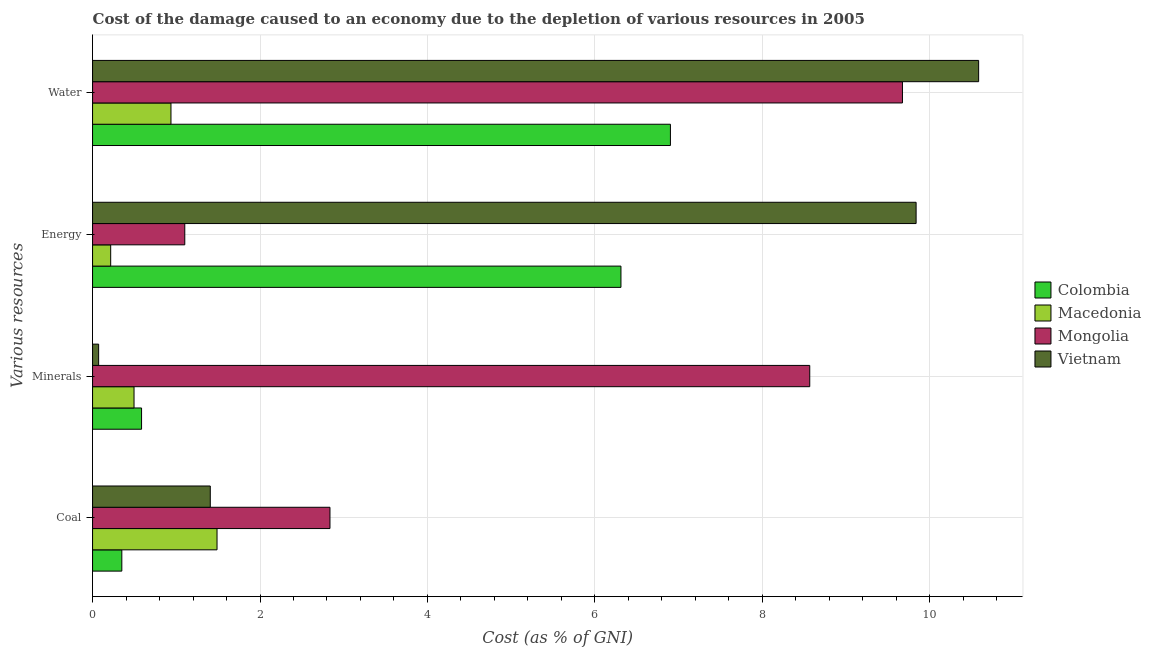How many bars are there on the 1st tick from the top?
Offer a very short reply. 4. How many bars are there on the 3rd tick from the bottom?
Give a very brief answer. 4. What is the label of the 3rd group of bars from the top?
Your response must be concise. Minerals. What is the cost of damage due to depletion of water in Macedonia?
Give a very brief answer. 0.94. Across all countries, what is the maximum cost of damage due to depletion of water?
Make the answer very short. 10.58. Across all countries, what is the minimum cost of damage due to depletion of water?
Keep it short and to the point. 0.94. In which country was the cost of damage due to depletion of coal maximum?
Ensure brevity in your answer.  Mongolia. In which country was the cost of damage due to depletion of energy minimum?
Your answer should be very brief. Macedonia. What is the total cost of damage due to depletion of minerals in the graph?
Make the answer very short. 9.72. What is the difference between the cost of damage due to depletion of coal in Mongolia and that in Macedonia?
Provide a short and direct response. 1.35. What is the difference between the cost of damage due to depletion of water in Mongolia and the cost of damage due to depletion of minerals in Macedonia?
Ensure brevity in your answer.  9.18. What is the average cost of damage due to depletion of water per country?
Offer a terse response. 7.02. What is the difference between the cost of damage due to depletion of coal and cost of damage due to depletion of energy in Colombia?
Make the answer very short. -5.96. What is the ratio of the cost of damage due to depletion of minerals in Colombia to that in Macedonia?
Provide a short and direct response. 1.18. Is the cost of damage due to depletion of minerals in Vietnam less than that in Macedonia?
Provide a short and direct response. Yes. What is the difference between the highest and the second highest cost of damage due to depletion of water?
Your response must be concise. 0.91. What is the difference between the highest and the lowest cost of damage due to depletion of minerals?
Offer a very short reply. 8.49. Is it the case that in every country, the sum of the cost of damage due to depletion of water and cost of damage due to depletion of energy is greater than the sum of cost of damage due to depletion of minerals and cost of damage due to depletion of coal?
Your answer should be compact. No. What does the 1st bar from the top in Water represents?
Make the answer very short. Vietnam. What does the 4th bar from the bottom in Minerals represents?
Ensure brevity in your answer.  Vietnam. How many bars are there?
Keep it short and to the point. 16. Are all the bars in the graph horizontal?
Your answer should be very brief. Yes. Are the values on the major ticks of X-axis written in scientific E-notation?
Your response must be concise. No. Does the graph contain any zero values?
Your answer should be compact. No. How are the legend labels stacked?
Your response must be concise. Vertical. What is the title of the graph?
Provide a succinct answer. Cost of the damage caused to an economy due to the depletion of various resources in 2005 . What is the label or title of the X-axis?
Provide a succinct answer. Cost (as % of GNI). What is the label or title of the Y-axis?
Keep it short and to the point. Various resources. What is the Cost (as % of GNI) of Colombia in Coal?
Keep it short and to the point. 0.35. What is the Cost (as % of GNI) of Macedonia in Coal?
Your response must be concise. 1.49. What is the Cost (as % of GNI) of Mongolia in Coal?
Provide a succinct answer. 2.84. What is the Cost (as % of GNI) of Vietnam in Coal?
Ensure brevity in your answer.  1.41. What is the Cost (as % of GNI) of Colombia in Minerals?
Your answer should be very brief. 0.59. What is the Cost (as % of GNI) of Macedonia in Minerals?
Give a very brief answer. 0.5. What is the Cost (as % of GNI) in Mongolia in Minerals?
Offer a terse response. 8.57. What is the Cost (as % of GNI) in Vietnam in Minerals?
Provide a succinct answer. 0.07. What is the Cost (as % of GNI) in Colombia in Energy?
Keep it short and to the point. 6.31. What is the Cost (as % of GNI) in Macedonia in Energy?
Provide a short and direct response. 0.22. What is the Cost (as % of GNI) of Mongolia in Energy?
Provide a succinct answer. 1.1. What is the Cost (as % of GNI) in Vietnam in Energy?
Give a very brief answer. 9.84. What is the Cost (as % of GNI) of Colombia in Water?
Provide a short and direct response. 6.9. What is the Cost (as % of GNI) in Macedonia in Water?
Provide a succinct answer. 0.94. What is the Cost (as % of GNI) in Mongolia in Water?
Give a very brief answer. 9.67. What is the Cost (as % of GNI) in Vietnam in Water?
Offer a terse response. 10.58. Across all Various resources, what is the maximum Cost (as % of GNI) of Colombia?
Ensure brevity in your answer.  6.9. Across all Various resources, what is the maximum Cost (as % of GNI) in Macedonia?
Provide a short and direct response. 1.49. Across all Various resources, what is the maximum Cost (as % of GNI) of Mongolia?
Provide a succinct answer. 9.67. Across all Various resources, what is the maximum Cost (as % of GNI) of Vietnam?
Offer a very short reply. 10.58. Across all Various resources, what is the minimum Cost (as % of GNI) in Colombia?
Offer a terse response. 0.35. Across all Various resources, what is the minimum Cost (as % of GNI) of Macedonia?
Your response must be concise. 0.22. Across all Various resources, what is the minimum Cost (as % of GNI) in Mongolia?
Offer a very short reply. 1.1. Across all Various resources, what is the minimum Cost (as % of GNI) of Vietnam?
Offer a very short reply. 0.07. What is the total Cost (as % of GNI) of Colombia in the graph?
Make the answer very short. 14.15. What is the total Cost (as % of GNI) of Macedonia in the graph?
Keep it short and to the point. 3.14. What is the total Cost (as % of GNI) in Mongolia in the graph?
Offer a terse response. 22.18. What is the total Cost (as % of GNI) in Vietnam in the graph?
Provide a succinct answer. 21.9. What is the difference between the Cost (as % of GNI) of Colombia in Coal and that in Minerals?
Provide a succinct answer. -0.24. What is the difference between the Cost (as % of GNI) in Mongolia in Coal and that in Minerals?
Ensure brevity in your answer.  -5.73. What is the difference between the Cost (as % of GNI) of Vietnam in Coal and that in Minerals?
Ensure brevity in your answer.  1.33. What is the difference between the Cost (as % of GNI) in Colombia in Coal and that in Energy?
Offer a very short reply. -5.96. What is the difference between the Cost (as % of GNI) in Macedonia in Coal and that in Energy?
Your response must be concise. 1.27. What is the difference between the Cost (as % of GNI) in Mongolia in Coal and that in Energy?
Offer a very short reply. 1.73. What is the difference between the Cost (as % of GNI) of Vietnam in Coal and that in Energy?
Offer a very short reply. -8.43. What is the difference between the Cost (as % of GNI) of Colombia in Coal and that in Water?
Your answer should be very brief. -6.55. What is the difference between the Cost (as % of GNI) of Macedonia in Coal and that in Water?
Offer a very short reply. 0.55. What is the difference between the Cost (as % of GNI) in Mongolia in Coal and that in Water?
Your answer should be compact. -6.84. What is the difference between the Cost (as % of GNI) of Vietnam in Coal and that in Water?
Offer a very short reply. -9.18. What is the difference between the Cost (as % of GNI) of Colombia in Minerals and that in Energy?
Make the answer very short. -5.73. What is the difference between the Cost (as % of GNI) in Macedonia in Minerals and that in Energy?
Your answer should be very brief. 0.28. What is the difference between the Cost (as % of GNI) in Mongolia in Minerals and that in Energy?
Your response must be concise. 7.47. What is the difference between the Cost (as % of GNI) of Vietnam in Minerals and that in Energy?
Keep it short and to the point. -9.76. What is the difference between the Cost (as % of GNI) of Colombia in Minerals and that in Water?
Give a very brief answer. -6.32. What is the difference between the Cost (as % of GNI) in Macedonia in Minerals and that in Water?
Offer a terse response. -0.44. What is the difference between the Cost (as % of GNI) in Mongolia in Minerals and that in Water?
Keep it short and to the point. -1.11. What is the difference between the Cost (as % of GNI) of Vietnam in Minerals and that in Water?
Your response must be concise. -10.51. What is the difference between the Cost (as % of GNI) of Colombia in Energy and that in Water?
Offer a very short reply. -0.59. What is the difference between the Cost (as % of GNI) of Macedonia in Energy and that in Water?
Keep it short and to the point. -0.72. What is the difference between the Cost (as % of GNI) in Mongolia in Energy and that in Water?
Keep it short and to the point. -8.57. What is the difference between the Cost (as % of GNI) of Vietnam in Energy and that in Water?
Your answer should be compact. -0.75. What is the difference between the Cost (as % of GNI) in Colombia in Coal and the Cost (as % of GNI) in Macedonia in Minerals?
Give a very brief answer. -0.15. What is the difference between the Cost (as % of GNI) of Colombia in Coal and the Cost (as % of GNI) of Mongolia in Minerals?
Ensure brevity in your answer.  -8.22. What is the difference between the Cost (as % of GNI) of Colombia in Coal and the Cost (as % of GNI) of Vietnam in Minerals?
Make the answer very short. 0.28. What is the difference between the Cost (as % of GNI) of Macedonia in Coal and the Cost (as % of GNI) of Mongolia in Minerals?
Your answer should be compact. -7.08. What is the difference between the Cost (as % of GNI) in Macedonia in Coal and the Cost (as % of GNI) in Vietnam in Minerals?
Your response must be concise. 1.41. What is the difference between the Cost (as % of GNI) in Mongolia in Coal and the Cost (as % of GNI) in Vietnam in Minerals?
Provide a short and direct response. 2.76. What is the difference between the Cost (as % of GNI) in Colombia in Coal and the Cost (as % of GNI) in Macedonia in Energy?
Your answer should be very brief. 0.13. What is the difference between the Cost (as % of GNI) of Colombia in Coal and the Cost (as % of GNI) of Mongolia in Energy?
Provide a succinct answer. -0.75. What is the difference between the Cost (as % of GNI) in Colombia in Coal and the Cost (as % of GNI) in Vietnam in Energy?
Provide a succinct answer. -9.49. What is the difference between the Cost (as % of GNI) of Macedonia in Coal and the Cost (as % of GNI) of Mongolia in Energy?
Provide a short and direct response. 0.39. What is the difference between the Cost (as % of GNI) in Macedonia in Coal and the Cost (as % of GNI) in Vietnam in Energy?
Offer a terse response. -8.35. What is the difference between the Cost (as % of GNI) in Mongolia in Coal and the Cost (as % of GNI) in Vietnam in Energy?
Offer a very short reply. -7. What is the difference between the Cost (as % of GNI) of Colombia in Coal and the Cost (as % of GNI) of Macedonia in Water?
Give a very brief answer. -0.59. What is the difference between the Cost (as % of GNI) of Colombia in Coal and the Cost (as % of GNI) of Mongolia in Water?
Provide a succinct answer. -9.32. What is the difference between the Cost (as % of GNI) in Colombia in Coal and the Cost (as % of GNI) in Vietnam in Water?
Provide a succinct answer. -10.23. What is the difference between the Cost (as % of GNI) of Macedonia in Coal and the Cost (as % of GNI) of Mongolia in Water?
Keep it short and to the point. -8.19. What is the difference between the Cost (as % of GNI) of Macedonia in Coal and the Cost (as % of GNI) of Vietnam in Water?
Offer a very short reply. -9.1. What is the difference between the Cost (as % of GNI) of Mongolia in Coal and the Cost (as % of GNI) of Vietnam in Water?
Make the answer very short. -7.75. What is the difference between the Cost (as % of GNI) of Colombia in Minerals and the Cost (as % of GNI) of Macedonia in Energy?
Make the answer very short. 0.37. What is the difference between the Cost (as % of GNI) of Colombia in Minerals and the Cost (as % of GNI) of Mongolia in Energy?
Offer a terse response. -0.52. What is the difference between the Cost (as % of GNI) in Colombia in Minerals and the Cost (as % of GNI) in Vietnam in Energy?
Offer a terse response. -9.25. What is the difference between the Cost (as % of GNI) in Macedonia in Minerals and the Cost (as % of GNI) in Mongolia in Energy?
Your response must be concise. -0.61. What is the difference between the Cost (as % of GNI) of Macedonia in Minerals and the Cost (as % of GNI) of Vietnam in Energy?
Provide a short and direct response. -9.34. What is the difference between the Cost (as % of GNI) in Mongolia in Minerals and the Cost (as % of GNI) in Vietnam in Energy?
Provide a succinct answer. -1.27. What is the difference between the Cost (as % of GNI) in Colombia in Minerals and the Cost (as % of GNI) in Macedonia in Water?
Your answer should be very brief. -0.35. What is the difference between the Cost (as % of GNI) in Colombia in Minerals and the Cost (as % of GNI) in Mongolia in Water?
Provide a succinct answer. -9.09. What is the difference between the Cost (as % of GNI) of Colombia in Minerals and the Cost (as % of GNI) of Vietnam in Water?
Your response must be concise. -10. What is the difference between the Cost (as % of GNI) of Macedonia in Minerals and the Cost (as % of GNI) of Mongolia in Water?
Make the answer very short. -9.18. What is the difference between the Cost (as % of GNI) of Macedonia in Minerals and the Cost (as % of GNI) of Vietnam in Water?
Offer a very short reply. -10.09. What is the difference between the Cost (as % of GNI) in Mongolia in Minerals and the Cost (as % of GNI) in Vietnam in Water?
Give a very brief answer. -2.02. What is the difference between the Cost (as % of GNI) of Colombia in Energy and the Cost (as % of GNI) of Macedonia in Water?
Offer a terse response. 5.37. What is the difference between the Cost (as % of GNI) in Colombia in Energy and the Cost (as % of GNI) in Mongolia in Water?
Offer a terse response. -3.36. What is the difference between the Cost (as % of GNI) of Colombia in Energy and the Cost (as % of GNI) of Vietnam in Water?
Your answer should be very brief. -4.27. What is the difference between the Cost (as % of GNI) in Macedonia in Energy and the Cost (as % of GNI) in Mongolia in Water?
Ensure brevity in your answer.  -9.46. What is the difference between the Cost (as % of GNI) of Macedonia in Energy and the Cost (as % of GNI) of Vietnam in Water?
Provide a short and direct response. -10.37. What is the difference between the Cost (as % of GNI) in Mongolia in Energy and the Cost (as % of GNI) in Vietnam in Water?
Your answer should be compact. -9.48. What is the average Cost (as % of GNI) of Colombia per Various resources?
Offer a terse response. 3.54. What is the average Cost (as % of GNI) in Macedonia per Various resources?
Ensure brevity in your answer.  0.78. What is the average Cost (as % of GNI) of Mongolia per Various resources?
Keep it short and to the point. 5.54. What is the average Cost (as % of GNI) in Vietnam per Various resources?
Provide a short and direct response. 5.47. What is the difference between the Cost (as % of GNI) of Colombia and Cost (as % of GNI) of Macedonia in Coal?
Give a very brief answer. -1.14. What is the difference between the Cost (as % of GNI) in Colombia and Cost (as % of GNI) in Mongolia in Coal?
Offer a very short reply. -2.49. What is the difference between the Cost (as % of GNI) of Colombia and Cost (as % of GNI) of Vietnam in Coal?
Provide a succinct answer. -1.06. What is the difference between the Cost (as % of GNI) of Macedonia and Cost (as % of GNI) of Mongolia in Coal?
Your response must be concise. -1.35. What is the difference between the Cost (as % of GNI) of Macedonia and Cost (as % of GNI) of Vietnam in Coal?
Ensure brevity in your answer.  0.08. What is the difference between the Cost (as % of GNI) in Mongolia and Cost (as % of GNI) in Vietnam in Coal?
Offer a very short reply. 1.43. What is the difference between the Cost (as % of GNI) in Colombia and Cost (as % of GNI) in Macedonia in Minerals?
Provide a succinct answer. 0.09. What is the difference between the Cost (as % of GNI) in Colombia and Cost (as % of GNI) in Mongolia in Minerals?
Make the answer very short. -7.98. What is the difference between the Cost (as % of GNI) in Colombia and Cost (as % of GNI) in Vietnam in Minerals?
Make the answer very short. 0.51. What is the difference between the Cost (as % of GNI) in Macedonia and Cost (as % of GNI) in Mongolia in Minerals?
Keep it short and to the point. -8.07. What is the difference between the Cost (as % of GNI) in Macedonia and Cost (as % of GNI) in Vietnam in Minerals?
Provide a short and direct response. 0.42. What is the difference between the Cost (as % of GNI) of Mongolia and Cost (as % of GNI) of Vietnam in Minerals?
Your answer should be very brief. 8.49. What is the difference between the Cost (as % of GNI) in Colombia and Cost (as % of GNI) in Macedonia in Energy?
Your response must be concise. 6.09. What is the difference between the Cost (as % of GNI) of Colombia and Cost (as % of GNI) of Mongolia in Energy?
Provide a short and direct response. 5.21. What is the difference between the Cost (as % of GNI) of Colombia and Cost (as % of GNI) of Vietnam in Energy?
Provide a succinct answer. -3.53. What is the difference between the Cost (as % of GNI) in Macedonia and Cost (as % of GNI) in Mongolia in Energy?
Offer a terse response. -0.88. What is the difference between the Cost (as % of GNI) in Macedonia and Cost (as % of GNI) in Vietnam in Energy?
Offer a very short reply. -9.62. What is the difference between the Cost (as % of GNI) in Mongolia and Cost (as % of GNI) in Vietnam in Energy?
Your answer should be compact. -8.74. What is the difference between the Cost (as % of GNI) in Colombia and Cost (as % of GNI) in Macedonia in Water?
Give a very brief answer. 5.97. What is the difference between the Cost (as % of GNI) in Colombia and Cost (as % of GNI) in Mongolia in Water?
Offer a very short reply. -2.77. What is the difference between the Cost (as % of GNI) of Colombia and Cost (as % of GNI) of Vietnam in Water?
Make the answer very short. -3.68. What is the difference between the Cost (as % of GNI) of Macedonia and Cost (as % of GNI) of Mongolia in Water?
Make the answer very short. -8.74. What is the difference between the Cost (as % of GNI) of Macedonia and Cost (as % of GNI) of Vietnam in Water?
Your response must be concise. -9.65. What is the difference between the Cost (as % of GNI) in Mongolia and Cost (as % of GNI) in Vietnam in Water?
Provide a short and direct response. -0.91. What is the ratio of the Cost (as % of GNI) of Colombia in Coal to that in Minerals?
Give a very brief answer. 0.6. What is the ratio of the Cost (as % of GNI) in Macedonia in Coal to that in Minerals?
Offer a terse response. 3. What is the ratio of the Cost (as % of GNI) of Mongolia in Coal to that in Minerals?
Provide a short and direct response. 0.33. What is the ratio of the Cost (as % of GNI) of Vietnam in Coal to that in Minerals?
Offer a very short reply. 19.38. What is the ratio of the Cost (as % of GNI) of Colombia in Coal to that in Energy?
Offer a very short reply. 0.06. What is the ratio of the Cost (as % of GNI) of Macedonia in Coal to that in Energy?
Ensure brevity in your answer.  6.87. What is the ratio of the Cost (as % of GNI) of Mongolia in Coal to that in Energy?
Provide a short and direct response. 2.57. What is the ratio of the Cost (as % of GNI) in Vietnam in Coal to that in Energy?
Ensure brevity in your answer.  0.14. What is the ratio of the Cost (as % of GNI) in Colombia in Coal to that in Water?
Make the answer very short. 0.05. What is the ratio of the Cost (as % of GNI) of Macedonia in Coal to that in Water?
Offer a very short reply. 1.59. What is the ratio of the Cost (as % of GNI) in Mongolia in Coal to that in Water?
Your response must be concise. 0.29. What is the ratio of the Cost (as % of GNI) of Vietnam in Coal to that in Water?
Your answer should be very brief. 0.13. What is the ratio of the Cost (as % of GNI) in Colombia in Minerals to that in Energy?
Ensure brevity in your answer.  0.09. What is the ratio of the Cost (as % of GNI) of Macedonia in Minerals to that in Energy?
Offer a very short reply. 2.29. What is the ratio of the Cost (as % of GNI) of Mongolia in Minerals to that in Energy?
Give a very brief answer. 7.78. What is the ratio of the Cost (as % of GNI) in Vietnam in Minerals to that in Energy?
Your answer should be compact. 0.01. What is the ratio of the Cost (as % of GNI) in Colombia in Minerals to that in Water?
Provide a succinct answer. 0.08. What is the ratio of the Cost (as % of GNI) in Macedonia in Minerals to that in Water?
Offer a terse response. 0.53. What is the ratio of the Cost (as % of GNI) of Mongolia in Minerals to that in Water?
Offer a terse response. 0.89. What is the ratio of the Cost (as % of GNI) of Vietnam in Minerals to that in Water?
Offer a very short reply. 0.01. What is the ratio of the Cost (as % of GNI) in Colombia in Energy to that in Water?
Offer a terse response. 0.91. What is the ratio of the Cost (as % of GNI) in Macedonia in Energy to that in Water?
Provide a succinct answer. 0.23. What is the ratio of the Cost (as % of GNI) in Mongolia in Energy to that in Water?
Make the answer very short. 0.11. What is the ratio of the Cost (as % of GNI) of Vietnam in Energy to that in Water?
Make the answer very short. 0.93. What is the difference between the highest and the second highest Cost (as % of GNI) of Colombia?
Your answer should be compact. 0.59. What is the difference between the highest and the second highest Cost (as % of GNI) in Macedonia?
Ensure brevity in your answer.  0.55. What is the difference between the highest and the second highest Cost (as % of GNI) of Mongolia?
Offer a very short reply. 1.11. What is the difference between the highest and the second highest Cost (as % of GNI) of Vietnam?
Make the answer very short. 0.75. What is the difference between the highest and the lowest Cost (as % of GNI) of Colombia?
Your answer should be very brief. 6.55. What is the difference between the highest and the lowest Cost (as % of GNI) of Macedonia?
Make the answer very short. 1.27. What is the difference between the highest and the lowest Cost (as % of GNI) in Mongolia?
Keep it short and to the point. 8.57. What is the difference between the highest and the lowest Cost (as % of GNI) of Vietnam?
Offer a very short reply. 10.51. 